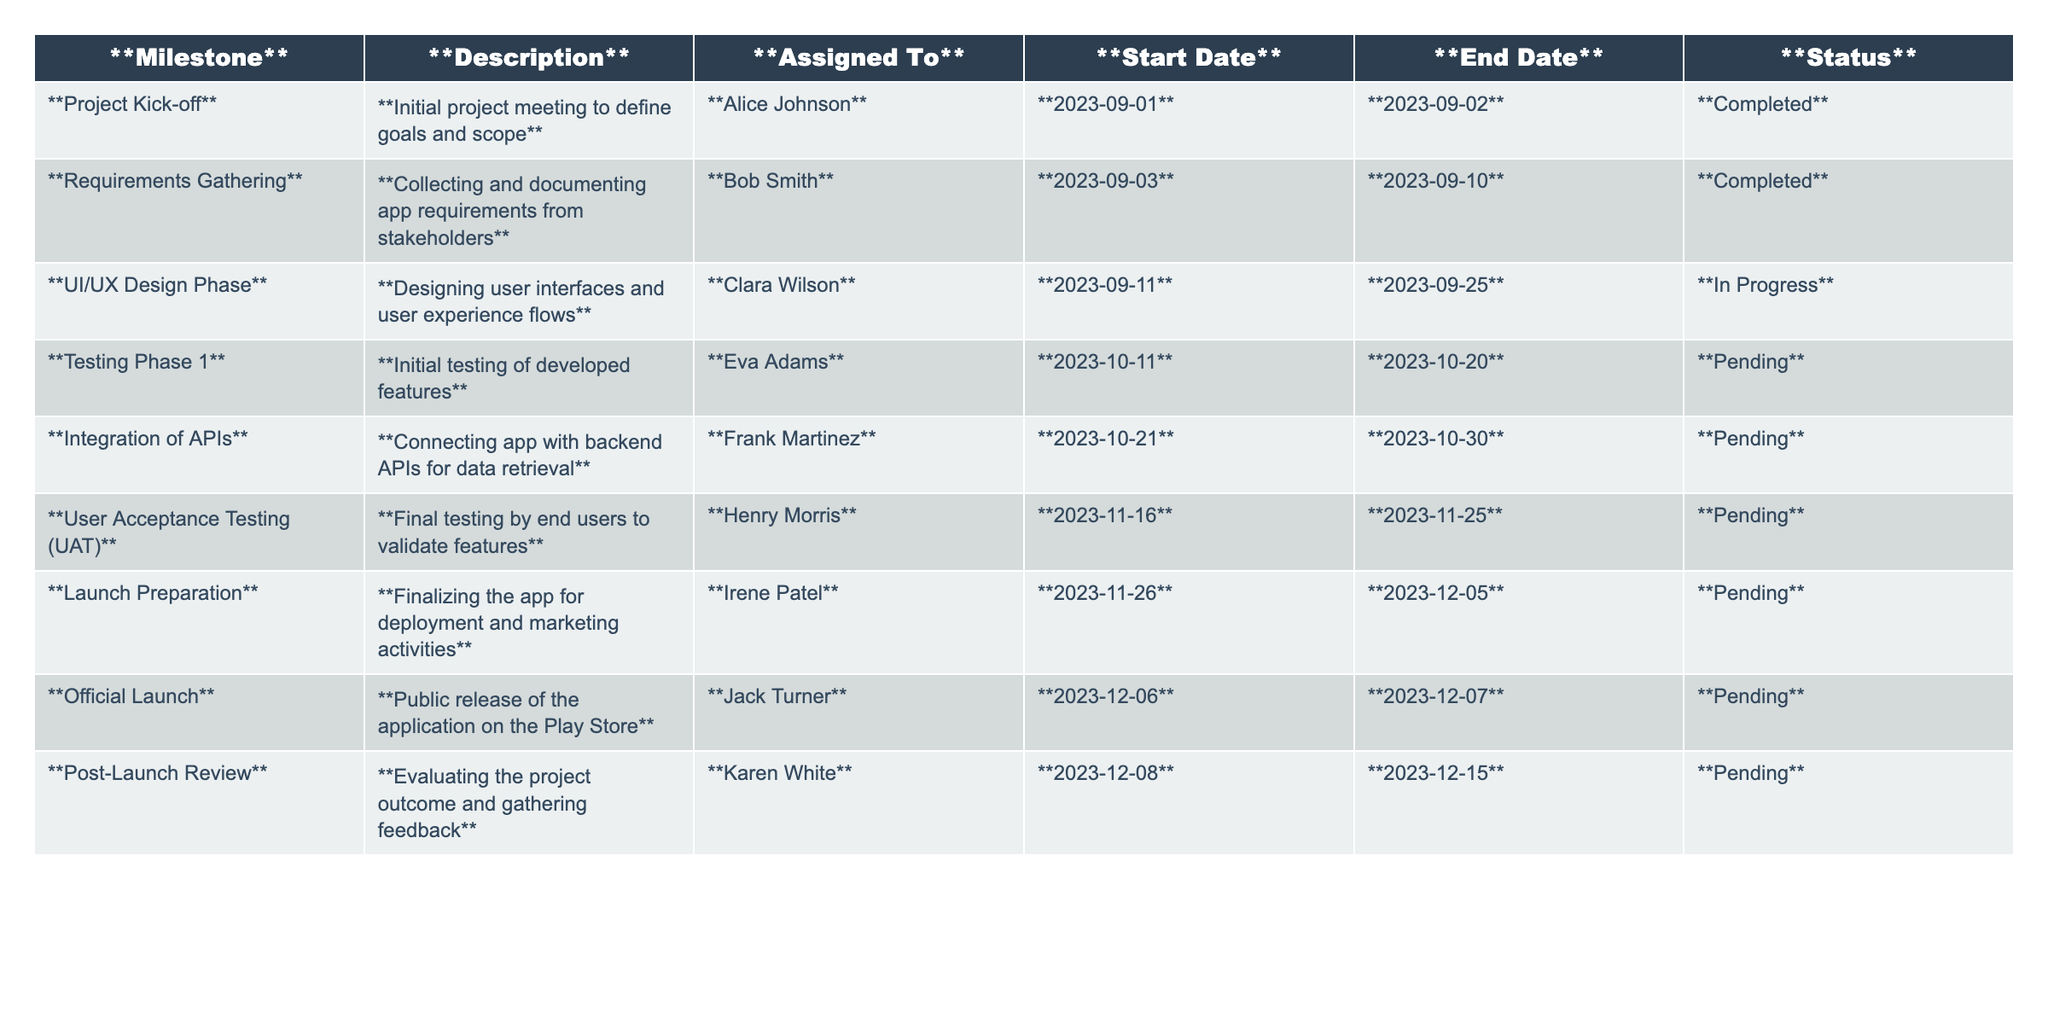What is the status of the UI/UX Design Phase? The table indicates that the UI/UX Design Phase, assigned to Clara Wilson, is currently marked as "In Progress."
Answer: In Progress Which milestone is assigned to Frank Martinez? According to the table, Frank Martinez is assigned to the milestone "Integration of APIs."
Answer: Integration of APIs How many milestones are currently marked as Pending? By counting the entries in the Status column, there are five milestones marked as "Pending."
Answer: 5 What are the start and end dates for User Acceptance Testing? The User Acceptance Testing milestone starts on 2023-11-16 and ends on 2023-11-25 as per the table.
Answer: Start: 2023-11-16, End: 2023-11-25 Is the Project Kick-off milestone completed? The table clearly shows that the Project Kick-off milestone is marked as "Completed."
Answer: Yes What is the difference in days between the start dates of the Launch Preparation and Official Launch milestones? Launch Preparation starts on 2023-11-26 and Official Launch starts on 2023-12-06; the difference is 10 days.
Answer: 10 days Who is responsible for the Testing Phase 1? Eva Adams is listed as the person assigned to the Testing Phase 1 milestone in the table.
Answer: Eva Adams Which milestone has the latest end date? The milestone with the latest end date is the Official Launch on 2023-12-07.
Answer: Official Launch Are there any milestones assigned to women? Yes, there are several milestones assigned to women, including Clara Wilson, Eva Adams, Irene Patel, and Karen White.
Answer: Yes What percentage of the milestones are completed? There are 2 completed milestones out of a total of 10, which is 20%.
Answer: 20% 